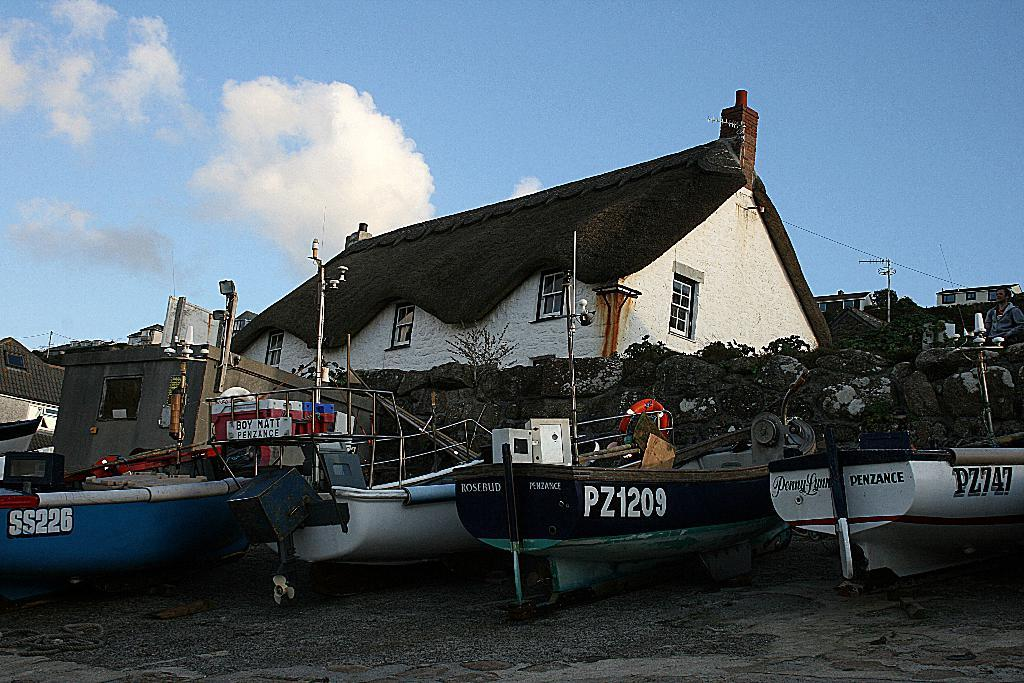What can be seen on the water body in the image? There are boats on a water body in the image. What is visible in the background of the image? There are buildings and trees in the background of the image. How would you describe the sky in the image? The sky is cloudy in the image. What type of suit is the parent wearing in the image? There is no parent or suit present in the image; it features boats on a water body with buildings, trees, and a cloudy sky in the background. 